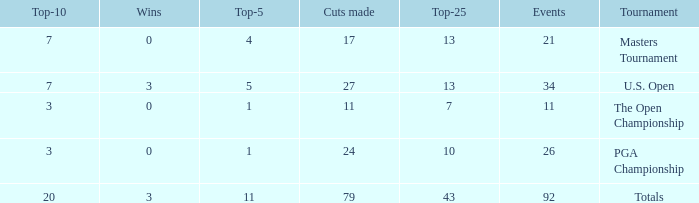Name the tournament for top-5 more thn 1 and top-25 of 13 with wins of 3 U.S. Open. 